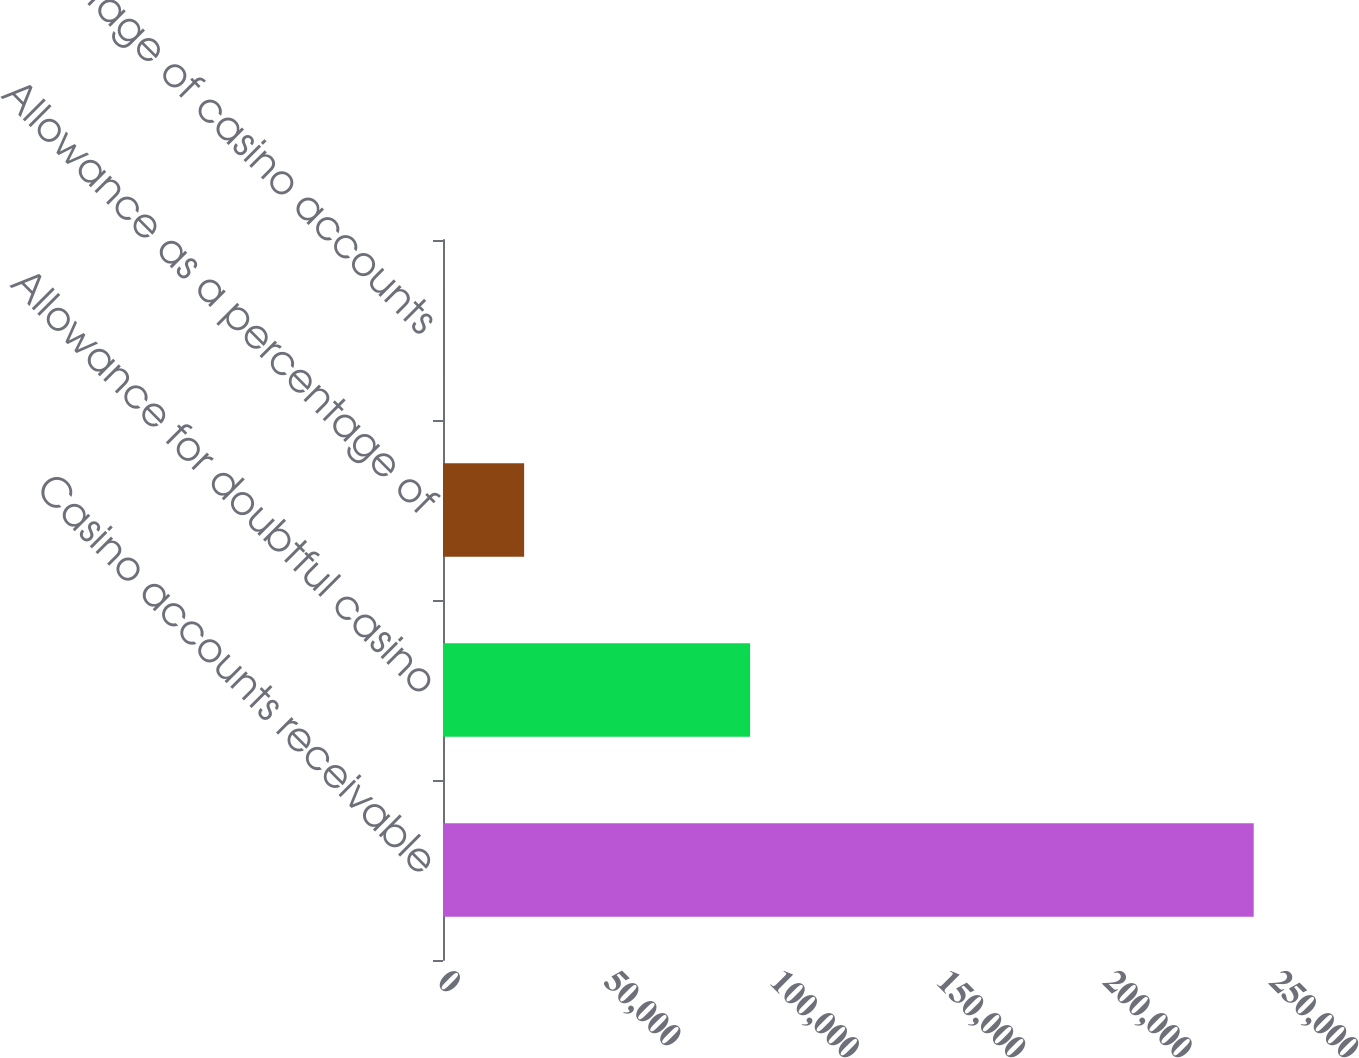Convert chart to OTSL. <chart><loc_0><loc_0><loc_500><loc_500><bar_chart><fcel>Casino accounts receivable<fcel>Allowance for doubtful casino<fcel>Allowance as a percentage of<fcel>Percentage of casino accounts<nl><fcel>243600<fcel>92278<fcel>24378.9<fcel>21<nl></chart> 